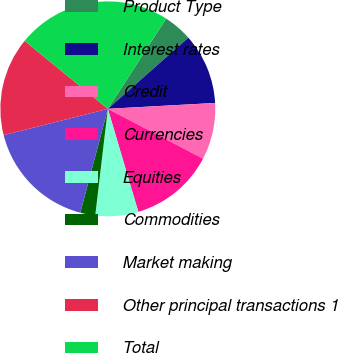<chart> <loc_0><loc_0><loc_500><loc_500><pie_chart><fcel>Product Type<fcel>Interest rates<fcel>Credit<fcel>Currencies<fcel>Equities<fcel>Commodities<fcel>Market making<fcel>Other principal transactions 1<fcel>Total<nl><fcel>4.35%<fcel>10.64%<fcel>8.55%<fcel>12.74%<fcel>6.45%<fcel>2.25%<fcel>16.94%<fcel>14.84%<fcel>23.23%<nl></chart> 